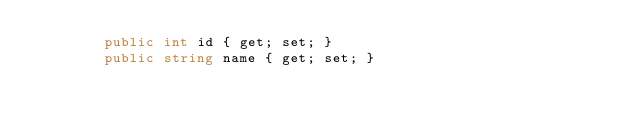<code> <loc_0><loc_0><loc_500><loc_500><_C#_>        public int id { get; set; }
        public string name { get; set; }
    </code> 